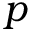<formula> <loc_0><loc_0><loc_500><loc_500>p</formula> 